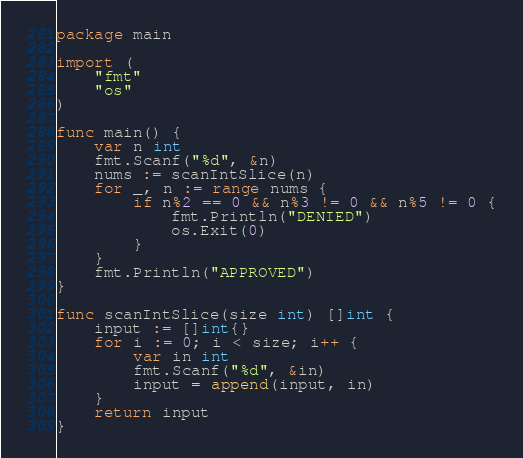<code> <loc_0><loc_0><loc_500><loc_500><_Go_>package main

import (
	"fmt"
	"os"
)

func main() {
	var n int
	fmt.Scanf("%d", &n)
	nums := scanIntSlice(n)
	for _, n := range nums {
		if n%2 == 0 && n%3 != 0 && n%5 != 0 {
			fmt.Println("DENIED")
			os.Exit(0)
		}
	}
	fmt.Println("APPROVED")
}

func scanIntSlice(size int) []int {
	input := []int{}
	for i := 0; i < size; i++ {
		var in int
		fmt.Scanf("%d", &in)
		input = append(input, in)
	}
	return input
}
</code> 